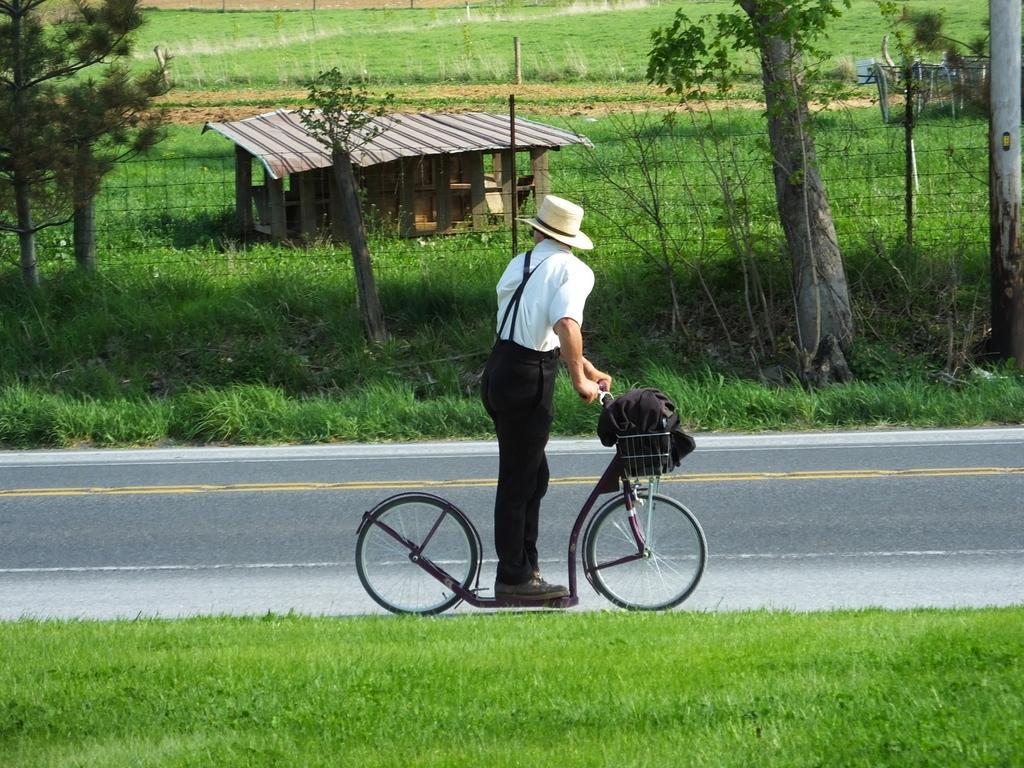How would you summarize this image in a sentence or two? There is a man standing on a cycle which is on the road. There is a grass on both sides of the road. In the background, there are trees, grass, a shed, field and a plant. 